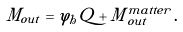<formula> <loc_0><loc_0><loc_500><loc_500>M _ { o u t } = \varphi _ { h } Q + M _ { \, o u t } ^ { m a t t e r } \, .</formula> 